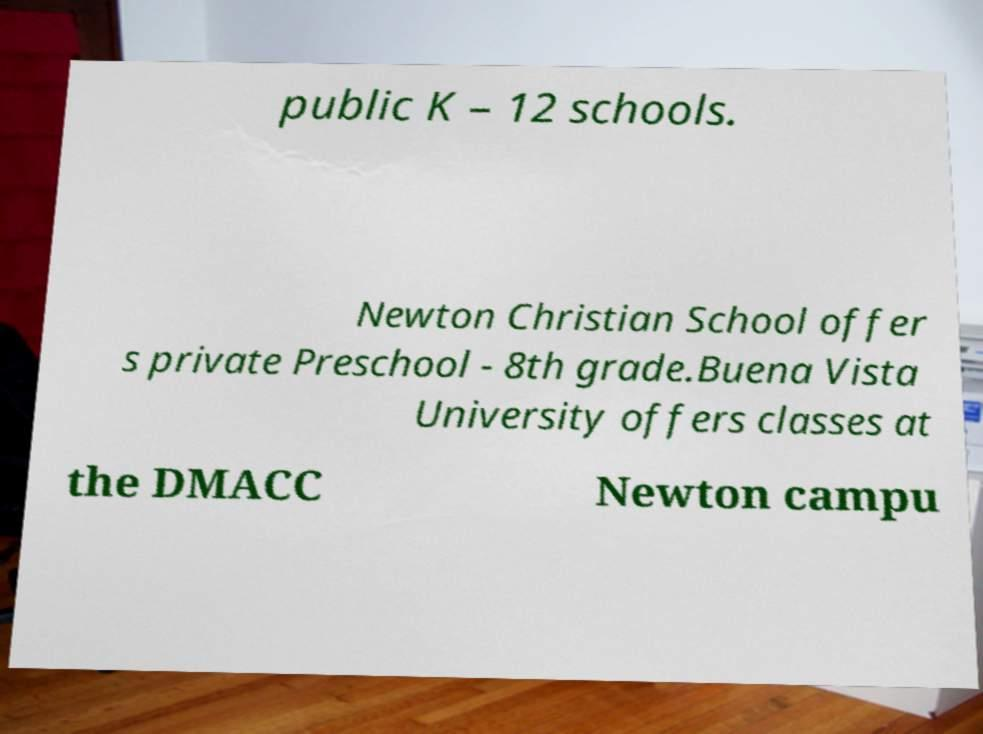Please identify and transcribe the text found in this image. public K – 12 schools. Newton Christian School offer s private Preschool - 8th grade.Buena Vista University offers classes at the DMACC Newton campu 